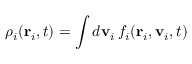<formula> <loc_0><loc_0><loc_500><loc_500>\rho _ { i } ( r _ { i } , t ) = \int d v _ { i } \, f _ { i } ( r _ { i } , v _ { i } , t )</formula> 